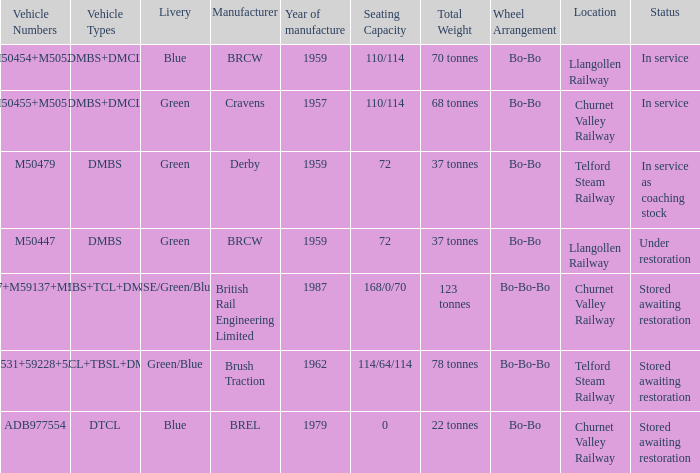What status is the vehicle numbers of adb977554? Stored awaiting restoration. Help me parse the entirety of this table. {'header': ['Vehicle Numbers', 'Vehicle Types', 'Livery', 'Manufacturer', 'Year of manufacture', 'Seating Capacity', 'Total Weight', 'Wheel Arrangement', 'Location', 'Status'], 'rows': [['M50454+M50528', 'DMBS+DMCL', 'Blue', 'BRCW', '1959', '110/114', '70 tonnes', 'Bo-Bo', 'Llangollen Railway', 'In service'], ['M50455+M50517', 'DMBS+DMCL', 'Green', 'Cravens', '1957', '110/114', '68 tonnes', 'Bo-Bo', 'Churnet Valley Railway', 'In service'], ['M50479', 'DMBS', 'Green', 'Derby', '1959', '72', '37 tonnes', 'Bo-Bo', 'Telford Steam Railway', 'In service as coaching stock'], ['M50447', 'DMBS', 'Green', 'BRCW', '1959', '72', '37 tonnes', 'Bo-Bo', 'Llangollen Railway', 'Under restoration'], ['53437+M59137+M53494', 'DMBS+TCL+DMCL', 'NSE/Green/Blue', 'British Rail Engineering Limited', '1987', '168/0/70', '123 tonnes', 'Bo-Bo-Bo', 'Churnet Valley Railway', 'Stored awaiting restoration'], ['M50531+59228+53556', 'DMCL+TBSL+DMCL', 'Green/Blue', 'Brush Traction', '1962', '114/64/114', '78 tonnes', 'Bo-Bo-Bo', 'Telford Steam Railway', 'Stored awaiting restoration'], ['ADB977554', 'DTCL', 'Blue', 'BREL', '1979', '0', '22 tonnes', 'Bo-Bo', 'Churnet Valley Railway', 'Stored awaiting restoration']]} 